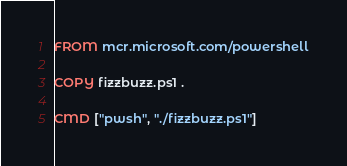<code> <loc_0><loc_0><loc_500><loc_500><_Dockerfile_>FROM mcr.microsoft.com/powershell

COPY fizzbuzz.ps1 .

CMD ["pwsh", "./fizzbuzz.ps1"]
</code> 